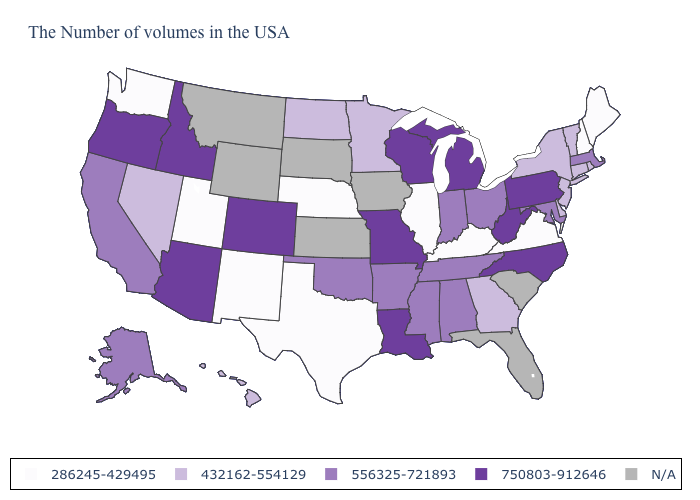What is the value of Indiana?
Be succinct. 556325-721893. Name the states that have a value in the range 432162-554129?
Quick response, please. Rhode Island, Vermont, Connecticut, New York, New Jersey, Delaware, Georgia, Minnesota, North Dakota, Nevada, Hawaii. Name the states that have a value in the range N/A?
Write a very short answer. South Carolina, Florida, Iowa, Kansas, South Dakota, Wyoming, Montana. What is the value of Louisiana?
Keep it brief. 750803-912646. Does Illinois have the lowest value in the USA?
Answer briefly. Yes. What is the value of Idaho?
Keep it brief. 750803-912646. Name the states that have a value in the range 750803-912646?
Keep it brief. Pennsylvania, North Carolina, West Virginia, Michigan, Wisconsin, Louisiana, Missouri, Colorado, Arizona, Idaho, Oregon. Name the states that have a value in the range 556325-721893?
Give a very brief answer. Massachusetts, Maryland, Ohio, Indiana, Alabama, Tennessee, Mississippi, Arkansas, Oklahoma, California, Alaska. Among the states that border New Hampshire , which have the highest value?
Quick response, please. Massachusetts. Among the states that border South Carolina , does Georgia have the highest value?
Short answer required. No. Which states hav the highest value in the South?
Quick response, please. North Carolina, West Virginia, Louisiana. Name the states that have a value in the range 286245-429495?
Short answer required. Maine, New Hampshire, Virginia, Kentucky, Illinois, Nebraska, Texas, New Mexico, Utah, Washington. What is the highest value in the Northeast ?
Give a very brief answer. 750803-912646. Name the states that have a value in the range 286245-429495?
Write a very short answer. Maine, New Hampshire, Virginia, Kentucky, Illinois, Nebraska, Texas, New Mexico, Utah, Washington. 